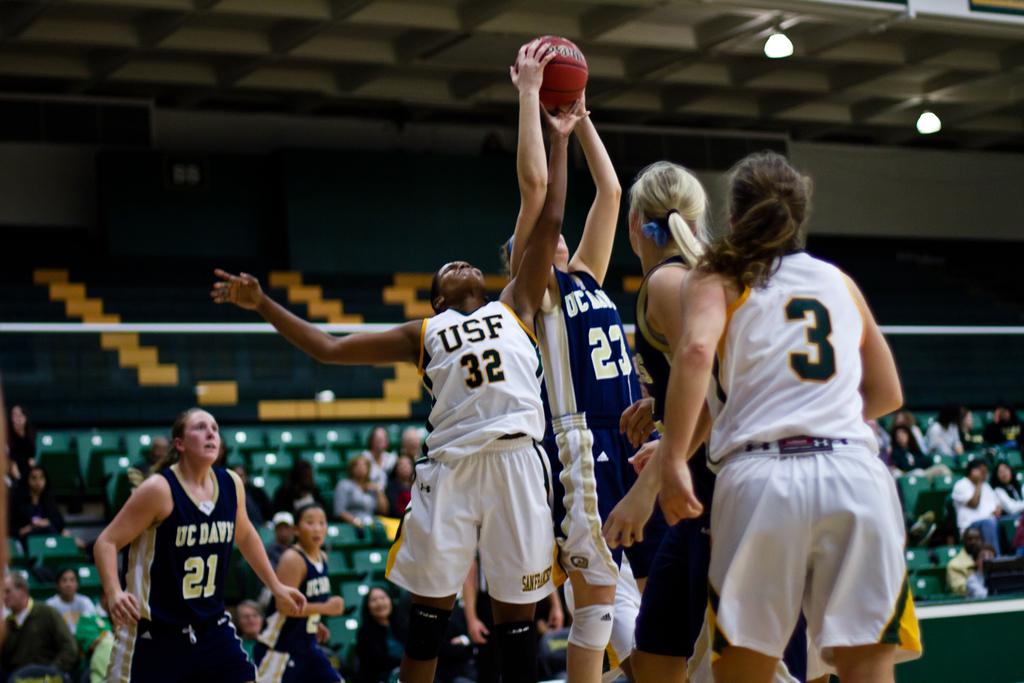What is the lowest jersey number that is visible?
Provide a short and direct response. 3. What team do the players in white play for?
Offer a terse response. Usf. 